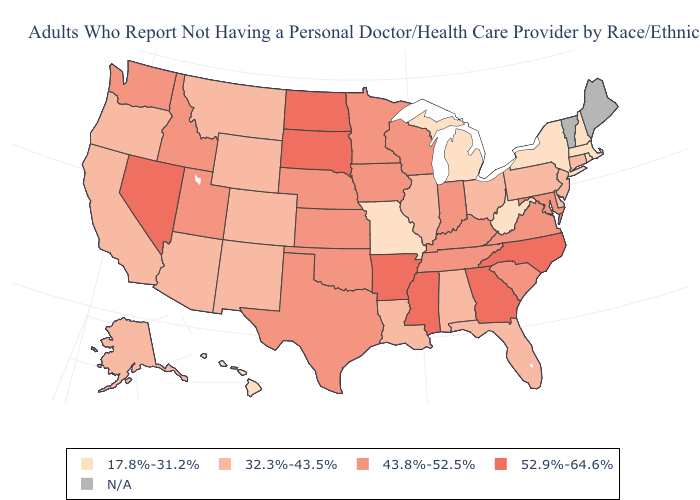Does Hawaii have the lowest value in the West?
Answer briefly. Yes. Name the states that have a value in the range N/A?
Short answer required. Maine, Vermont. Name the states that have a value in the range 43.8%-52.5%?
Be succinct. Idaho, Indiana, Iowa, Kansas, Kentucky, Maryland, Minnesota, Nebraska, Oklahoma, South Carolina, Tennessee, Texas, Utah, Virginia, Washington, Wisconsin. What is the value of Louisiana?
Give a very brief answer. 32.3%-43.5%. Which states have the highest value in the USA?
Write a very short answer. Arkansas, Georgia, Mississippi, Nevada, North Carolina, North Dakota, South Dakota. What is the lowest value in the USA?
Give a very brief answer. 17.8%-31.2%. How many symbols are there in the legend?
Quick response, please. 5. Among the states that border California , which have the highest value?
Write a very short answer. Nevada. Is the legend a continuous bar?
Quick response, please. No. Which states have the highest value in the USA?
Answer briefly. Arkansas, Georgia, Mississippi, Nevada, North Carolina, North Dakota, South Dakota. Does the map have missing data?
Answer briefly. Yes. Does North Dakota have the highest value in the MidWest?
Quick response, please. Yes. What is the value of Washington?
Give a very brief answer. 43.8%-52.5%. Among the states that border Virginia , does North Carolina have the highest value?
Concise answer only. Yes. 